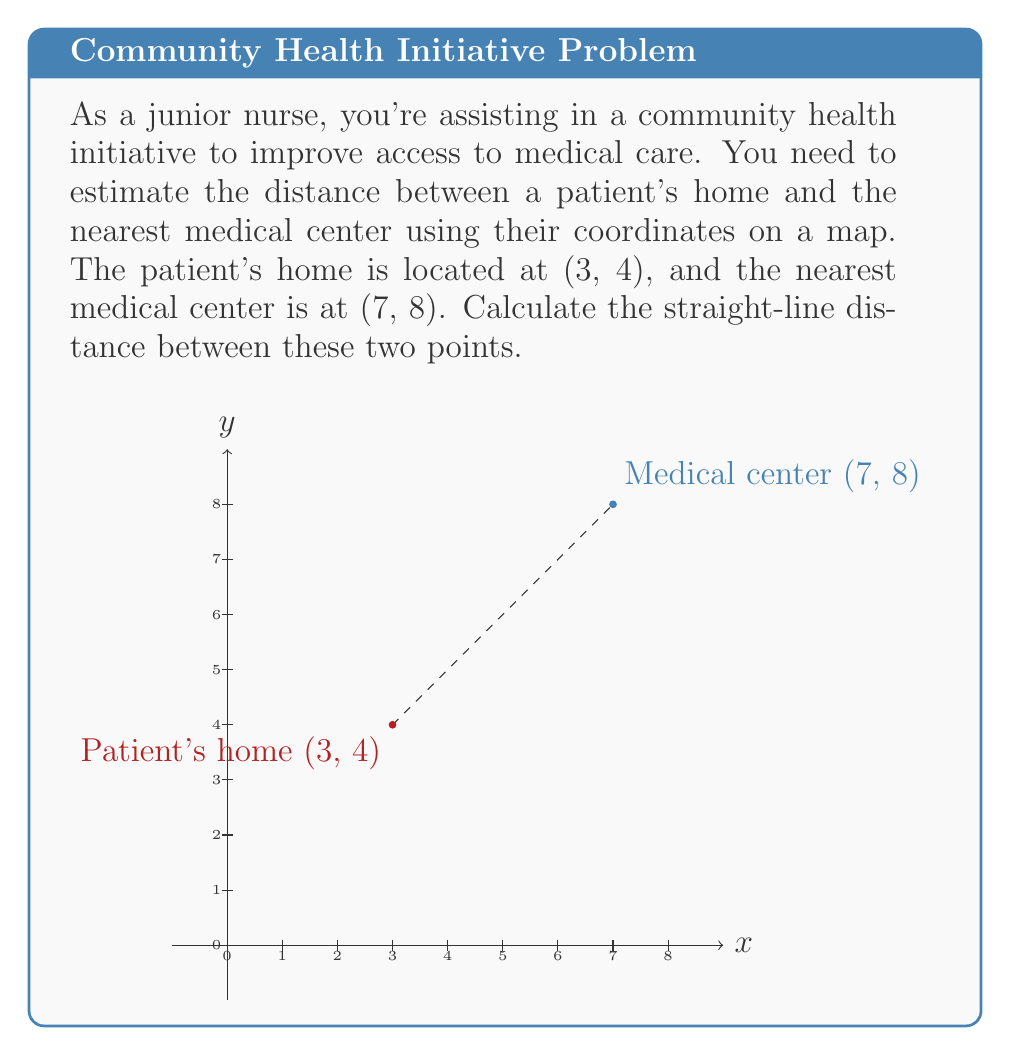Give your solution to this math problem. To solve this problem, we'll use the distance formula derived from the Pythagorean theorem:

$$d = \sqrt{(x_2 - x_1)^2 + (y_2 - y_1)^2}$$

Where $(x_1, y_1)$ is the patient's home and $(x_2, y_2)$ is the medical center.

Step 1: Identify the coordinates
- Patient's home: $(x_1, y_1) = (3, 4)$
- Medical center: $(x_2, y_2) = (7, 8)$

Step 2: Plug the values into the distance formula
$$d = \sqrt{(7 - 3)^2 + (8 - 4)^2}$$

Step 3: Simplify the expressions inside the parentheses
$$d = \sqrt{4^2 + 4^2}$$

Step 4: Calculate the squares
$$d = \sqrt{16 + 16}$$

Step 5: Add the values under the square root
$$d = \sqrt{32}$$

Step 6: Simplify the square root
$$d = 4\sqrt{2}$$

This result, $4\sqrt{2}$, represents the distance in the same units as the coordinate system (e.g., kilometers or miles).
Answer: $4\sqrt{2}$ units 